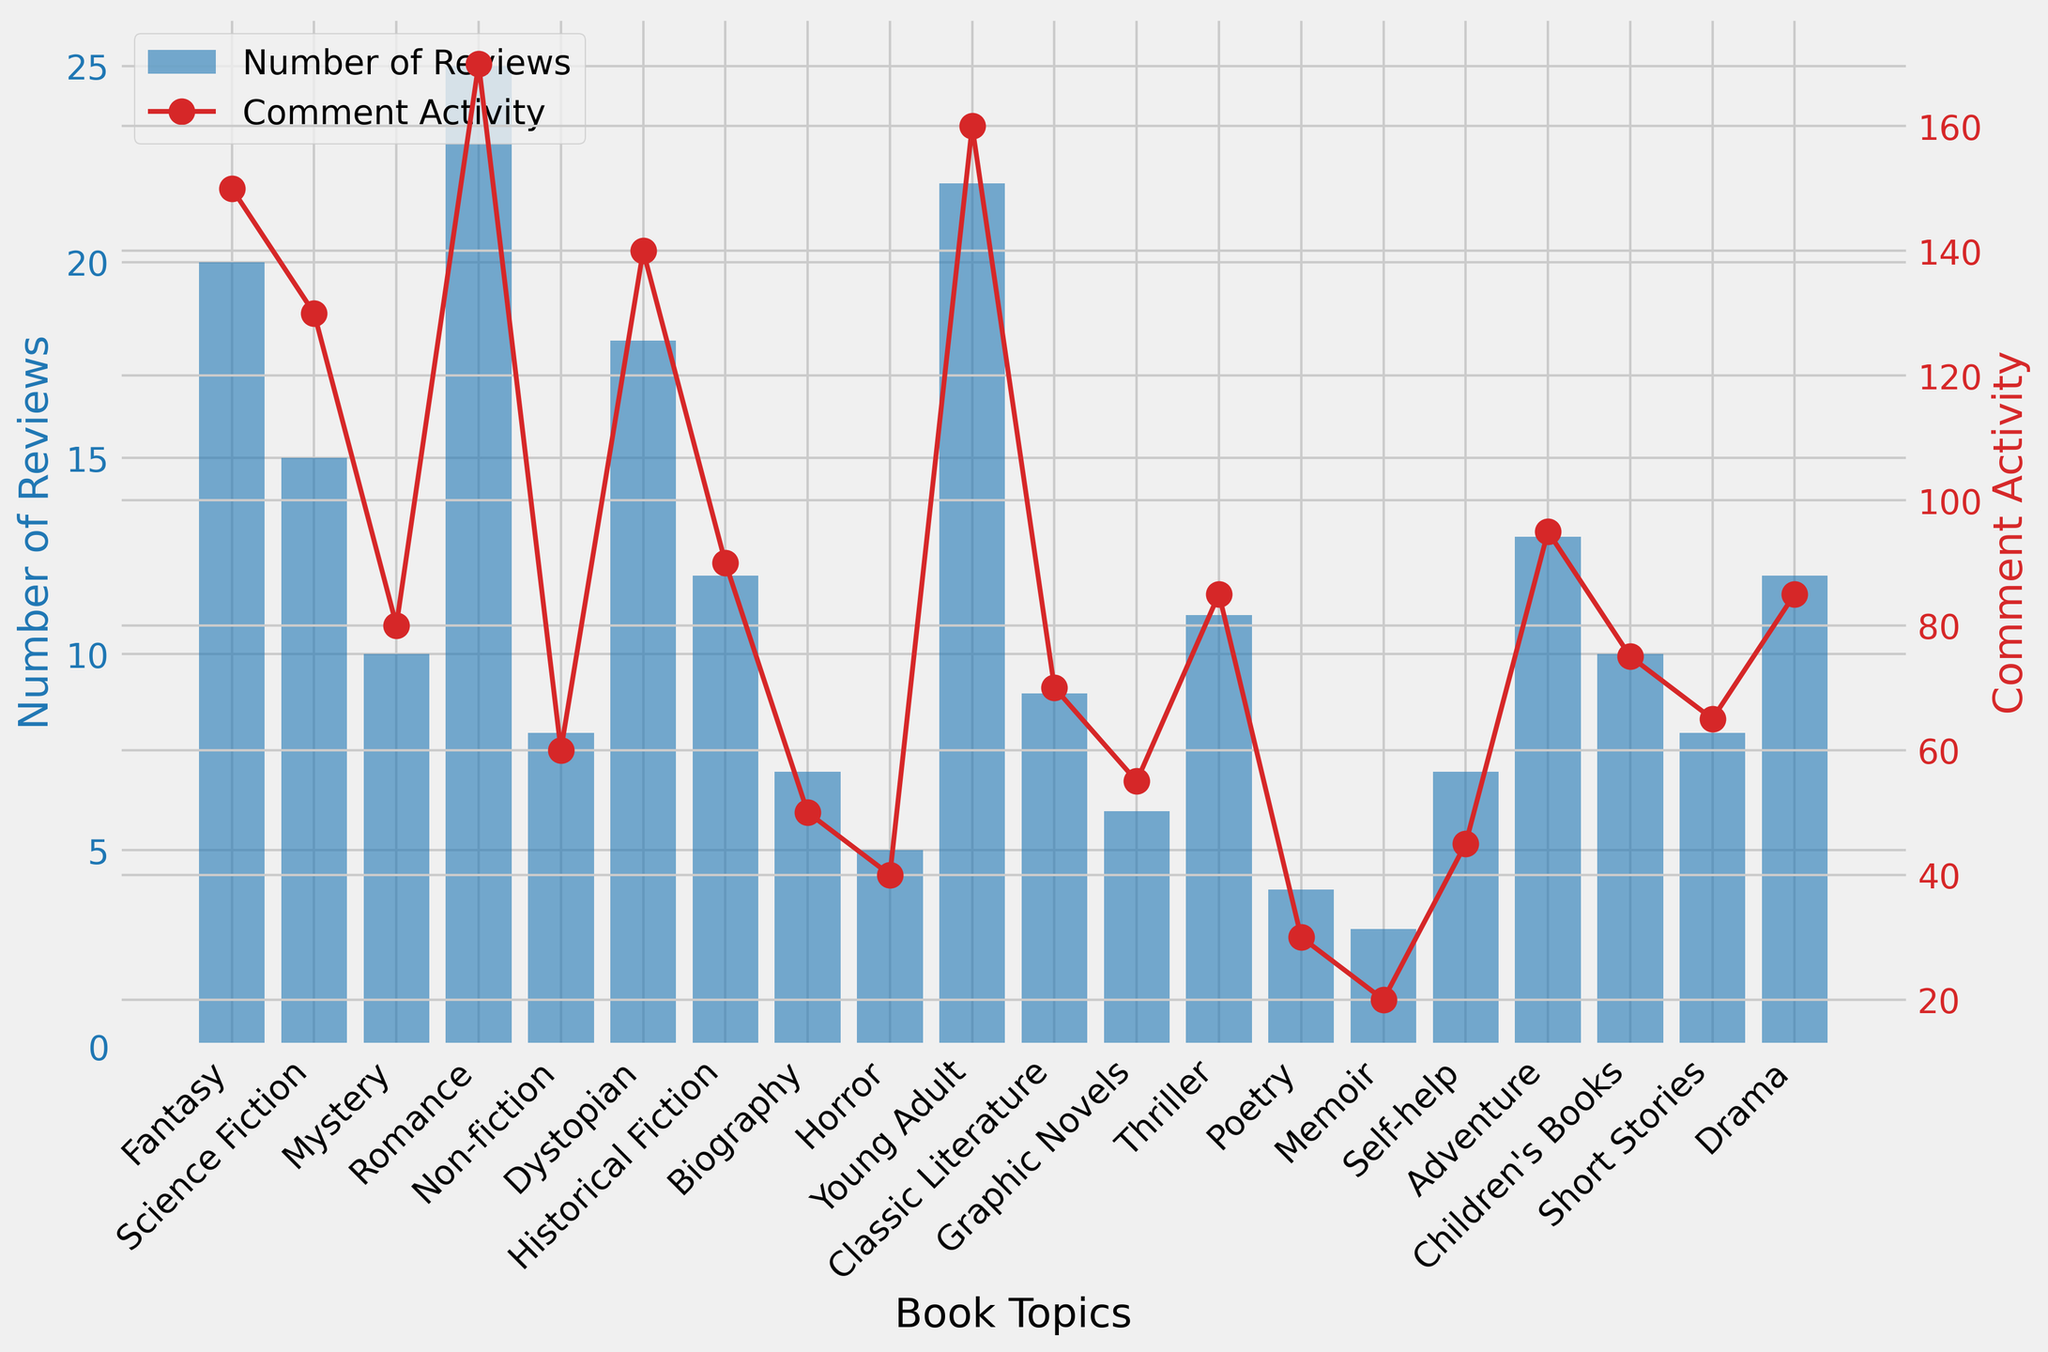How many more reviews does the topic with the highest number of reviews have compared to the topic with the lowest number of reviews? The topic with the highest number of reviews is Romance with 25 reviews, and the topic with the lowest number of reviews is Memoir with 3 reviews. The difference is 25 - 3 = 22.
Answer: 22 Which topic has the highest comment activity, and what is that value? The topic with the highest comment activity is Romance, which has a comment activity value of 170.
Answer: Romance, 170 Which book topic has the smallest difference between the number of reviews and the comment activity? Calculating the differences for each topic, the smallest difference is for Drama with 12 reviews and 85 comments, resulting in a difference of 85 - 12 = 73.
Answer: Drama What is the average comment activity for topics with more than 15 reviews? Topics with more than 15 reviews are Fantasy (150), Science Fiction (130), Romance (170), Dystopian (140), Young Adult (160). The average comment activity is (150 + 130 + 170 + 140 + 160)/ 5 = 150.
Answer: 150 How does the number of reviews for the "Young Adult" genre compare to the "Mystery" genre? The Young Adult genre has 22 reviews and the Mystery genre has 10 reviews. 22 is greater than 10.
Answer: Young Adult has more reviews than Mystery What is the difference between the comment activity for the topics "Fantasy" and "Science Fiction"? Fantasy has a comment activity of 150, Science Fiction has 130. The difference is 150 - 130 = 20.
Answer: 20 Identify two genres with the same number of comment activities and their values. Drama and Thriller both have a comment activity of 85.
Answer: Drama and Thriller, 85 Which genre shows the highest number of reviews with non-fiction-related content, and what is that number of reviews? Romance has the highest number of reviews among non-fiction-related genres with 25 reviews.
Answer: Romance, 25 What is the total number of reviews for genres that have fewer than 10 reviews each? The genres with fewer than 10 reviews are Non-fiction (8), Biography (7), Horror (5), Classic Literature (9), Graphic Novels (6), Poetry (4), Memoir (3), Self-help (7). Total: 8 + 7 + 5 + 9 + 6 + 4 + 3 + 7 = 49.
Answer: 49 How does the comment activity trend relate to the number of reviews across different book topics? Generally, there is a positive correlation between the number of reviews and the comment activity, with some outliers such as "Drama" and "Thriller."
Answer: Positive correlation with some outliers 